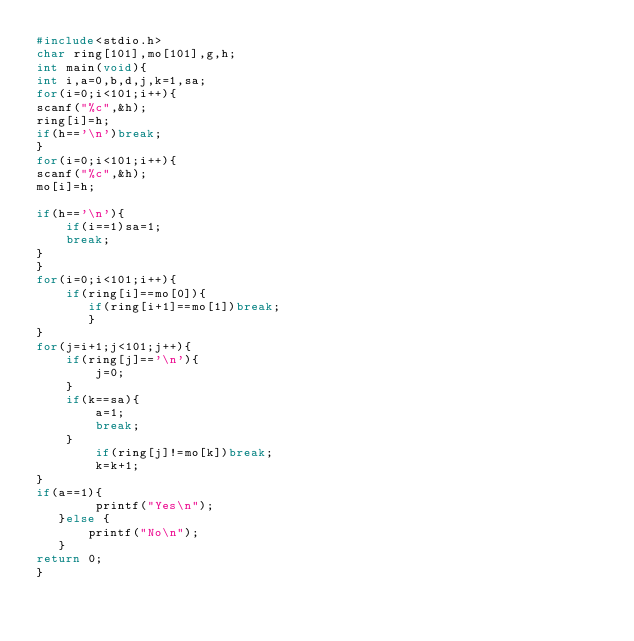Convert code to text. <code><loc_0><loc_0><loc_500><loc_500><_C_>#include<stdio.h>
char ring[101],mo[101],g,h;
int main(void){
int i,a=0,b,d,j,k=1,sa;
for(i=0;i<101;i++){
scanf("%c",&h);
ring[i]=h;
if(h=='\n')break;
}
for(i=0;i<101;i++){
scanf("%c",&h);
mo[i]=h;

if(h=='\n'){
    if(i==1)sa=1;
    break;
}
}
for(i=0;i<101;i++){
    if(ring[i]==mo[0]){
       if(ring[i+1]==mo[1])break;
       }
}
for(j=i+1;j<101;j++){
    if(ring[j]=='\n'){
        j=0;
    }
    if(k==sa){
        a=1;
        break;
    }
        if(ring[j]!=mo[k])break;
        k=k+1;
}
if(a==1){
        printf("Yes\n");
   }else {
       printf("No\n");
   }
return 0;
}</code> 